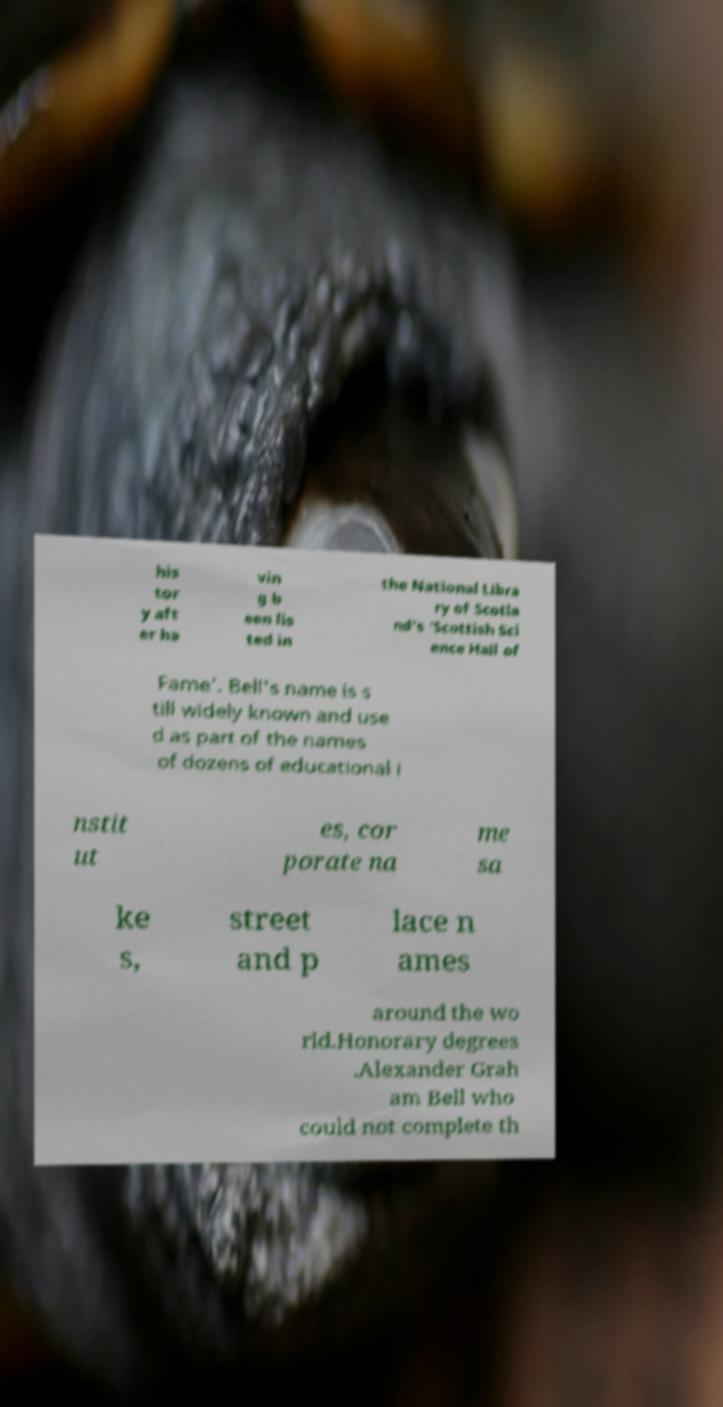For documentation purposes, I need the text within this image transcribed. Could you provide that? his tor y aft er ha vin g b een lis ted in the National Libra ry of Scotla nd's 'Scottish Sci ence Hall of Fame'. Bell's name is s till widely known and use d as part of the names of dozens of educational i nstit ut es, cor porate na me sa ke s, street and p lace n ames around the wo rld.Honorary degrees .Alexander Grah am Bell who could not complete th 